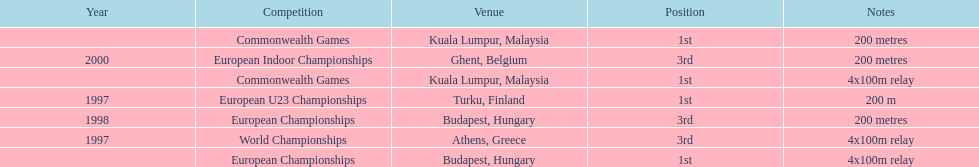List the competitions that have the same relay as world championships from athens, greece. European Championships, Commonwealth Games. 